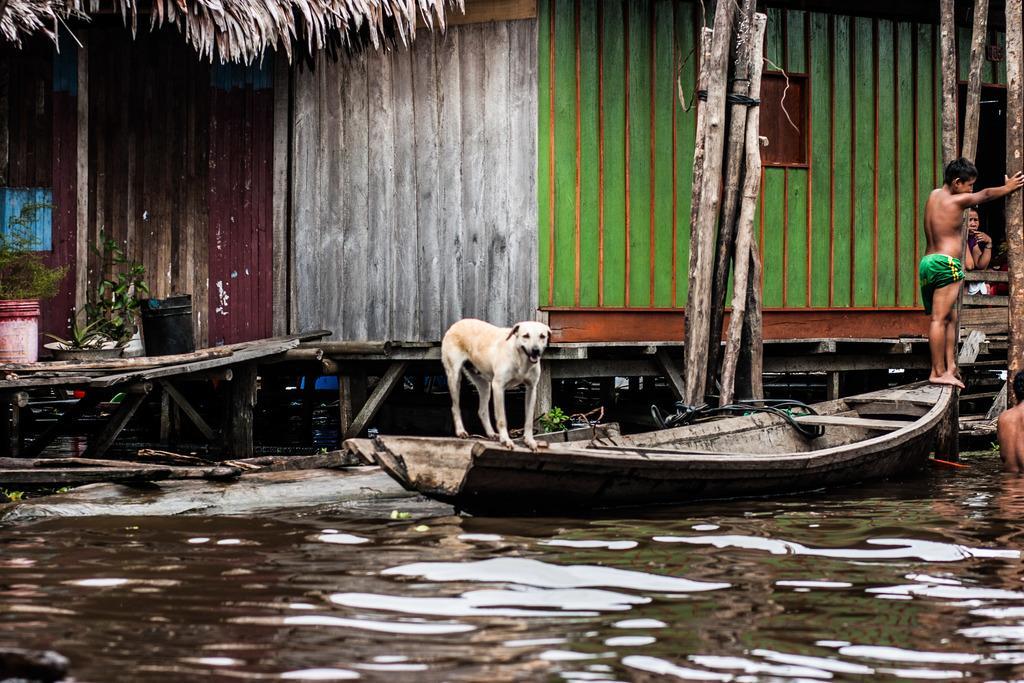Please provide a concise description of this image. In this image I can see a dog standing on the boat. The dog is in white and brown color. To the right I can see few people. I can see one person is inside the house, one person is standing on the boat and another person is on the water. To the left I can see few buckets and the plants. In the back I can see the house. 